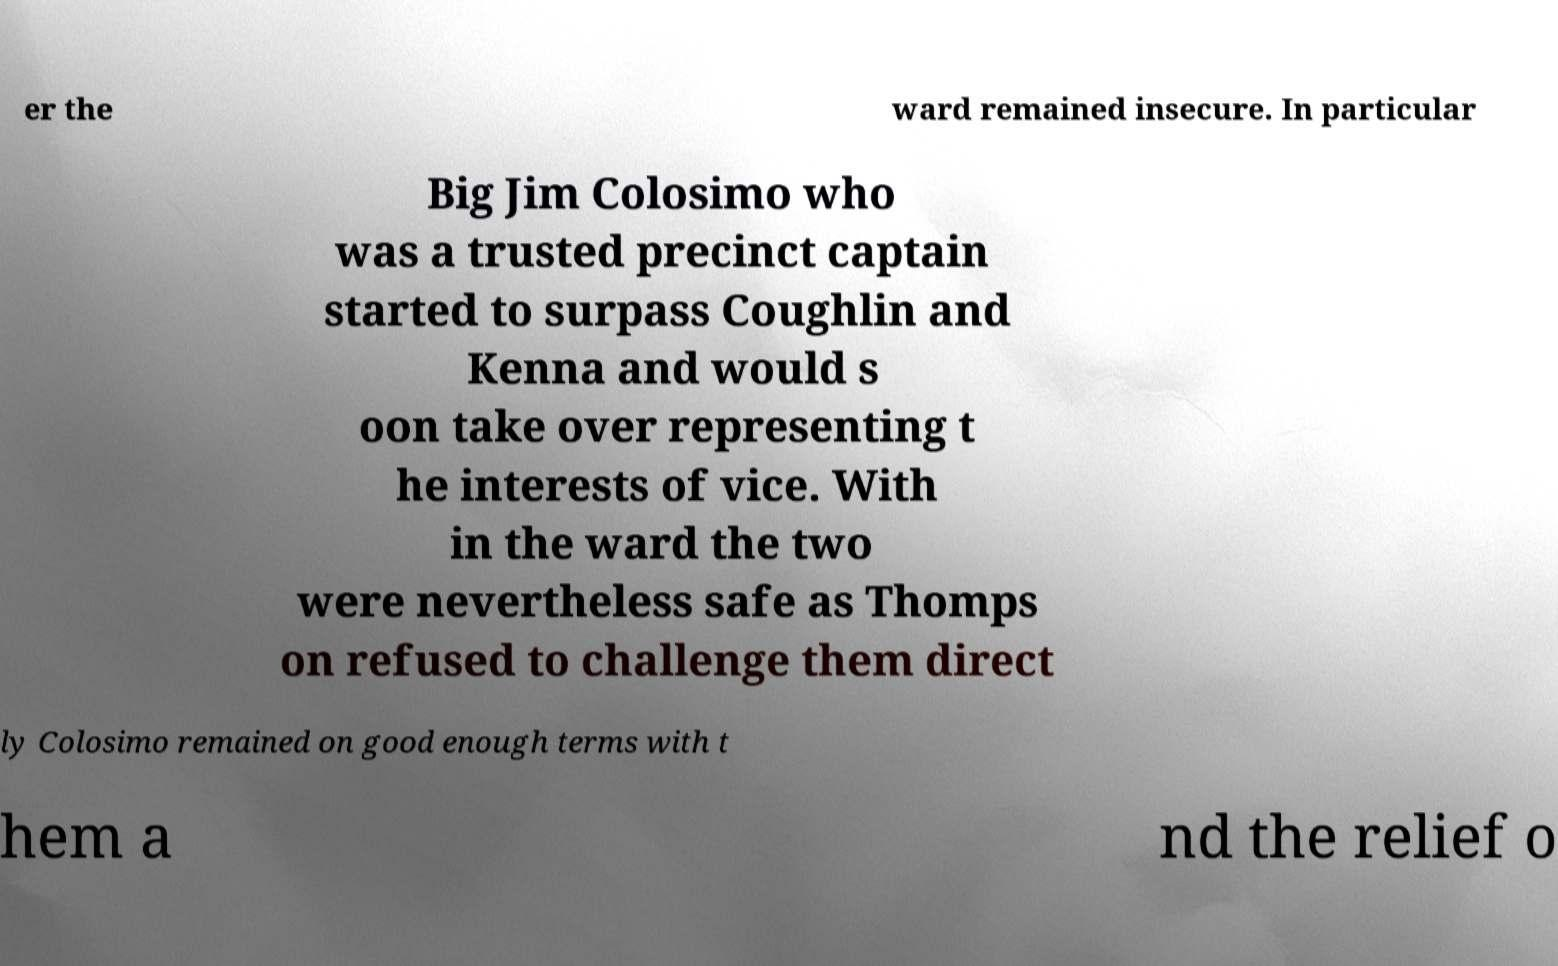Can you accurately transcribe the text from the provided image for me? er the ward remained insecure. In particular Big Jim Colosimo who was a trusted precinct captain started to surpass Coughlin and Kenna and would s oon take over representing t he interests of vice. With in the ward the two were nevertheless safe as Thomps on refused to challenge them direct ly Colosimo remained on good enough terms with t hem a nd the relief o 